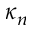Convert formula to latex. <formula><loc_0><loc_0><loc_500><loc_500>\kappa _ { n }</formula> 